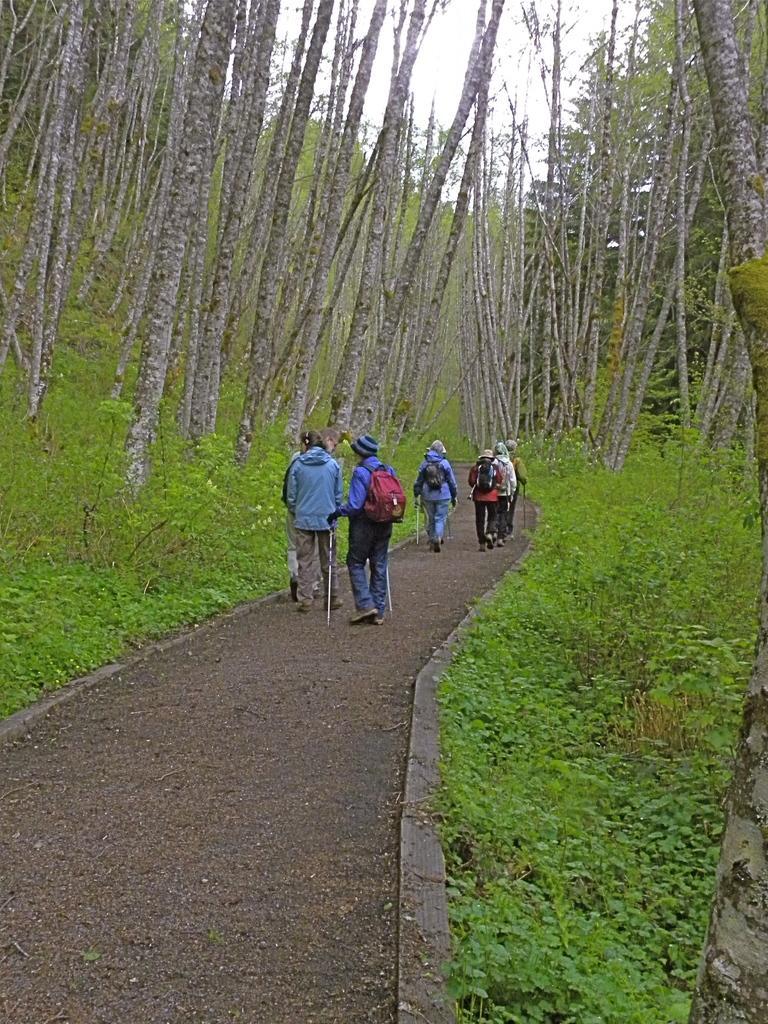Describe this image in one or two sentences. There are few people wearing back pack bag,holding two sticks and walking along the pathway. These are the small bushes and plants. I can see tall trees beside the pathway. 